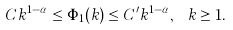<formula> <loc_0><loc_0><loc_500><loc_500>C k ^ { 1 - \alpha } \leq \Phi _ { 1 } ( k ) \leq C ^ { \prime } k ^ { 1 - \alpha } , \ k \geq 1 .</formula> 